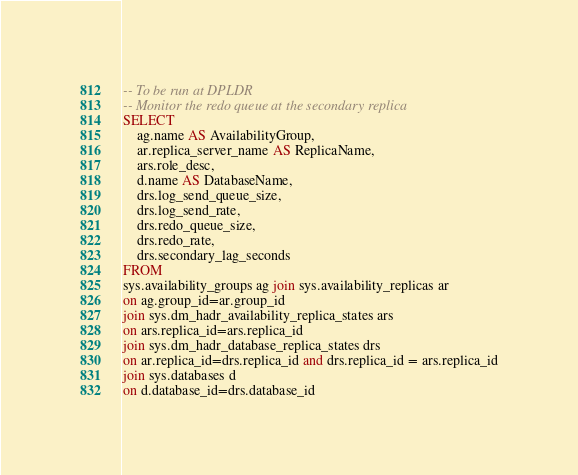Convert code to text. <code><loc_0><loc_0><loc_500><loc_500><_SQL_>-- To be run at DPLDR
-- Monitor the redo queue at the secondary replica
SELECT 
	ag.name AS AvailabilityGroup,
	ar.replica_server_name AS ReplicaName,
	ars.role_desc,
	d.name AS DatabaseName,
	drs.log_send_queue_size,
	drs.log_send_rate,
	drs.redo_queue_size,
	drs.redo_rate,
	drs.secondary_lag_seconds
FROM 
sys.availability_groups ag join sys.availability_replicas ar 
on ag.group_id=ar.group_id
join sys.dm_hadr_availability_replica_states ars 
on ars.replica_id=ars.replica_id
join sys.dm_hadr_database_replica_states drs
on ar.replica_id=drs.replica_id and drs.replica_id = ars.replica_id
join sys.databases d 
on d.database_id=drs.database_id 
</code> 